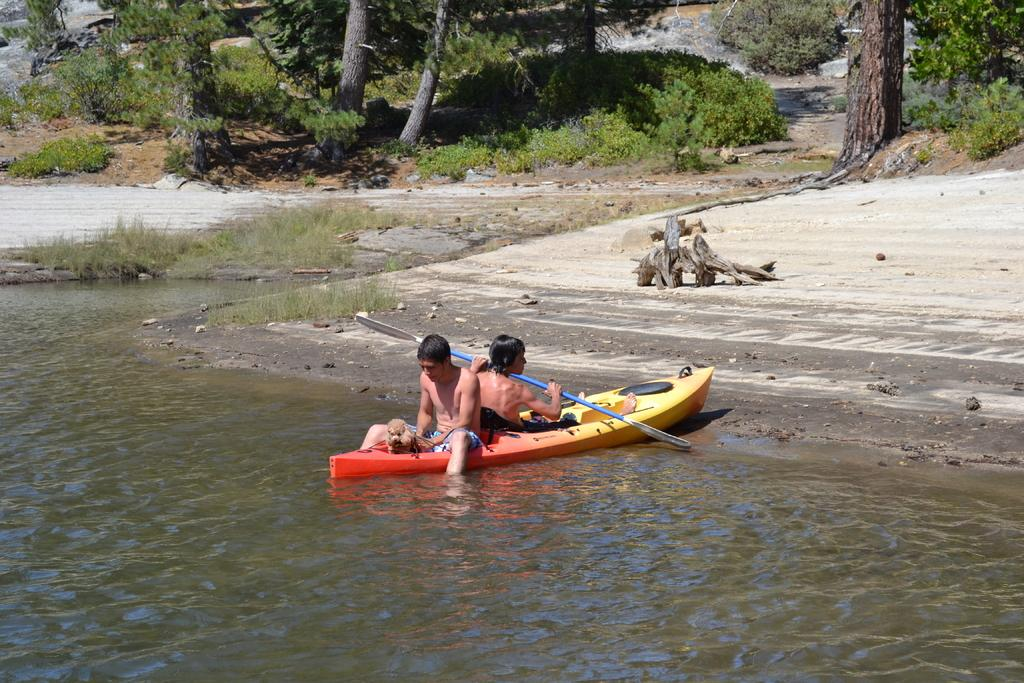How many people are on the boat in the image? There are two persons on a boat in the image. What is the boat sailing on? The boat is sailing on a river. What can be seen in the background of the image? There are trees, plants, and stones in the background of the image. What is visible at the bottom of the image? There is water visible at the bottom of the image. Can you tell me how many deer are visible in the image? There are no deer present in the image; it features two persons on a boat sailing on a river. What type of creature is shown interacting with the stones in the image? There is no creature shown interacting with the stones in the image; only the two persons on the boat and the surrounding environment are present. 